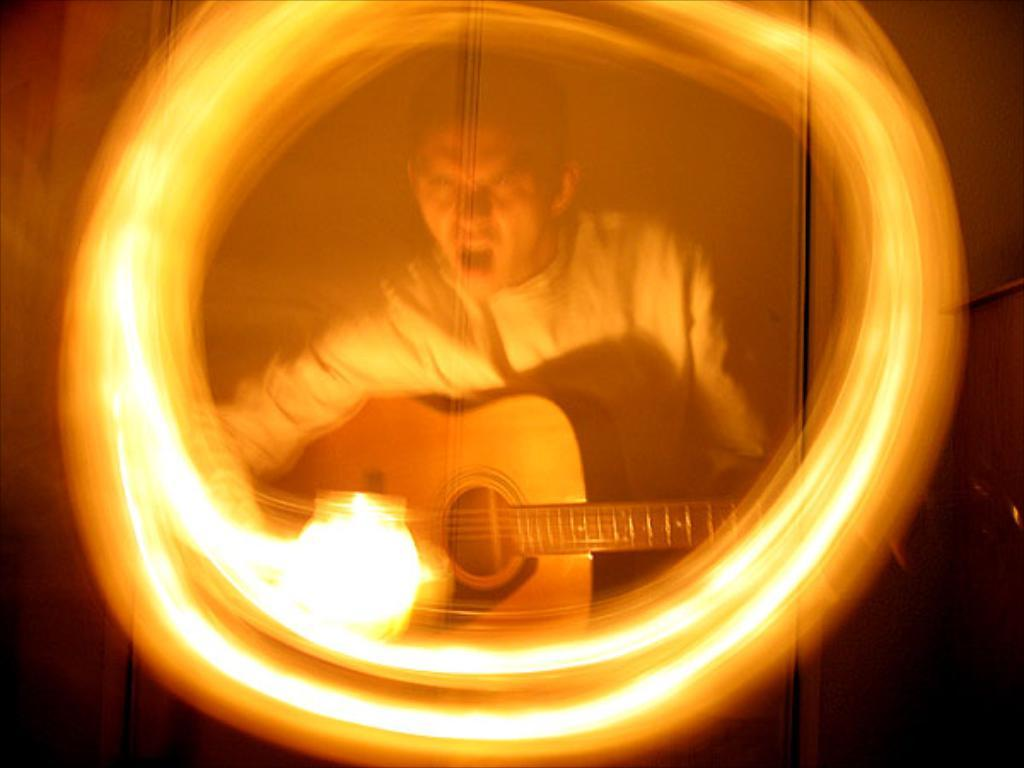What is the person in the image doing? The person is playing a guitar in the image. Can you describe any other objects or features in the image? Yes, there is an orange-colored hole in the image. Where is the orange-colored hole located? The orange-colored hole is placed on a photo frame. What type of scarecrow is standing next to the person playing the guitar in the image? There is no scarecrow present in the image. What shape is the orange-colored hole in the image? The shape of the orange-colored hole is not mentioned in the facts, so we cannot determine its shape from the information provided. 